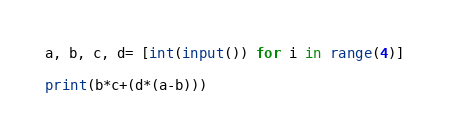<code> <loc_0><loc_0><loc_500><loc_500><_Python_>a, b, c, d= [int(input()) for i in range(4)]

print(b*c+(d*(a-b)))</code> 